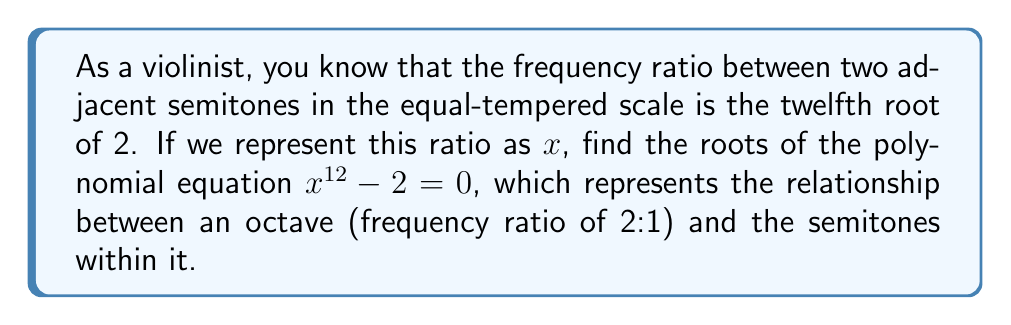Solve this math problem. Let's approach this step-by-step:

1) The equation we need to solve is $x^{12} - 2 = 0$

2) This is a polynomial equation where $x$ represents the frequency ratio between adjacent semitones.

3) We can rewrite this equation as $x^{12} = 2$

4) Taking the 12th root of both sides:

   $\sqrt[12]{x^{12}} = \sqrt[12]{2}$

   $x = \sqrt[12]{2}$

5) This gives us the principal root, which is the positive real root.

6) However, in complex number theory, an nth root equation always has n distinct roots in the complex plane.

7) The general formula for these roots is:

   $x_k = \sqrt[12]{2} \cdot e^{\frac{2\pi i k}{12}}$ for $k = 0, 1, 2, ..., 11$

8) These roots form a regular dodecagon in the complex plane, with the principal root $\sqrt[12]{2}$ lying on the positive real axis.

9) The 12 roots are:

   $x_0 = \sqrt[12]{2}$
   $x_1 = \sqrt[12]{2} \cdot e^{\frac{2\pi i}{12}}$
   $x_2 = \sqrt[12]{2} \cdot e^{\frac{4\pi i}{12}}$
   ...
   $x_{11} = \sqrt[12]{2} \cdot e^{\frac{22\pi i}{12}}$

10) In musical terms, $x_0$ represents the frequency ratio between adjacent semitones, while the other roots don't have direct musical significance but complete the mathematical solution.
Answer: The roots of the equation $x^{12} - 2 = 0$ are:

$x_k = \sqrt[12]{2} \cdot e^{\frac{2\pi i k}{12}}$ for $k = 0, 1, 2, ..., 11$

Where $\sqrt[12]{2} \approx 1.0594631$ is the frequency ratio between adjacent semitones in the equal-tempered scale. 